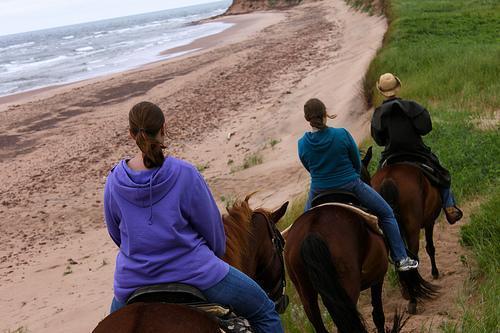How many people are wearing hats?
Give a very brief answer. 1. 